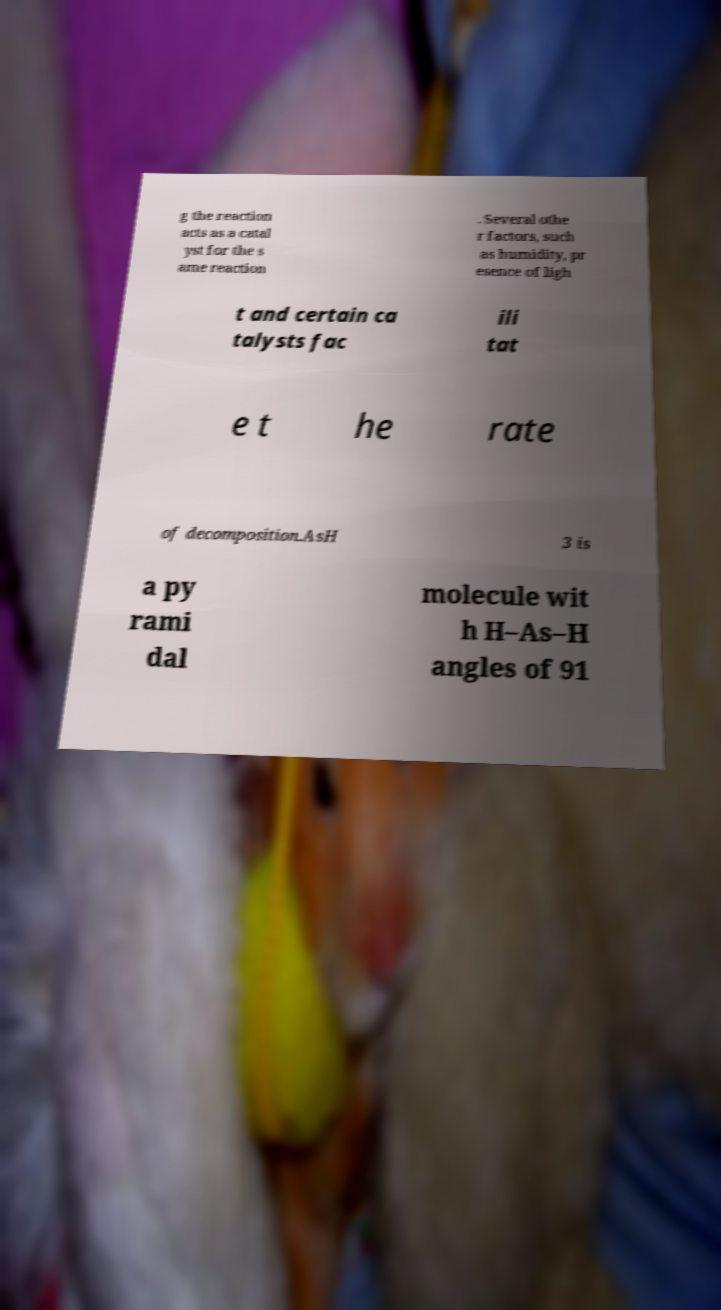Please read and relay the text visible in this image. What does it say? g the reaction acts as a catal yst for the s ame reaction . Several othe r factors, such as humidity, pr esence of ligh t and certain ca talysts fac ili tat e t he rate of decomposition.AsH 3 is a py rami dal molecule wit h H–As–H angles of 91 